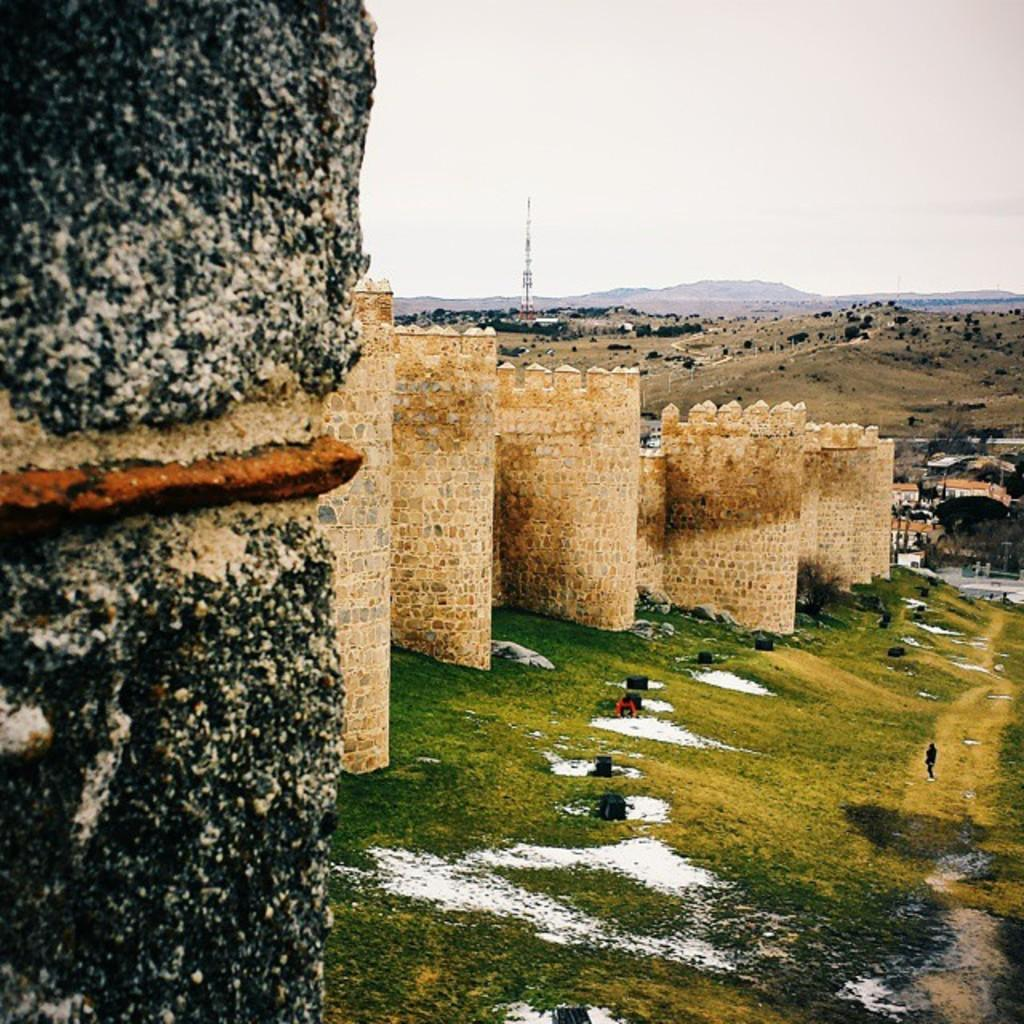What type of structure is the main subject of the image? There is a fort in the image. What can be seen in the background of the image? There are hills and a tower in the background of the image. What is the color of the sky in the image? The sky is visible in the background of the image. What type of vegetation is at the bottom of the image? There is grass at the bottom of the image. What type of experience can be gained by exploring the cave in the image? There is no cave present in the image; it features a fort, hills, a tower, and grass. 